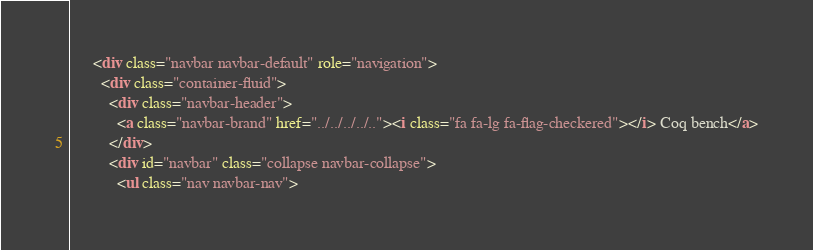Convert code to text. <code><loc_0><loc_0><loc_500><loc_500><_HTML_>      <div class="navbar navbar-default" role="navigation">
        <div class="container-fluid">
          <div class="navbar-header">
            <a class="navbar-brand" href="../../../../.."><i class="fa fa-lg fa-flag-checkered"></i> Coq bench</a>
          </div>
          <div id="navbar" class="collapse navbar-collapse">
            <ul class="nav navbar-nav"></code> 